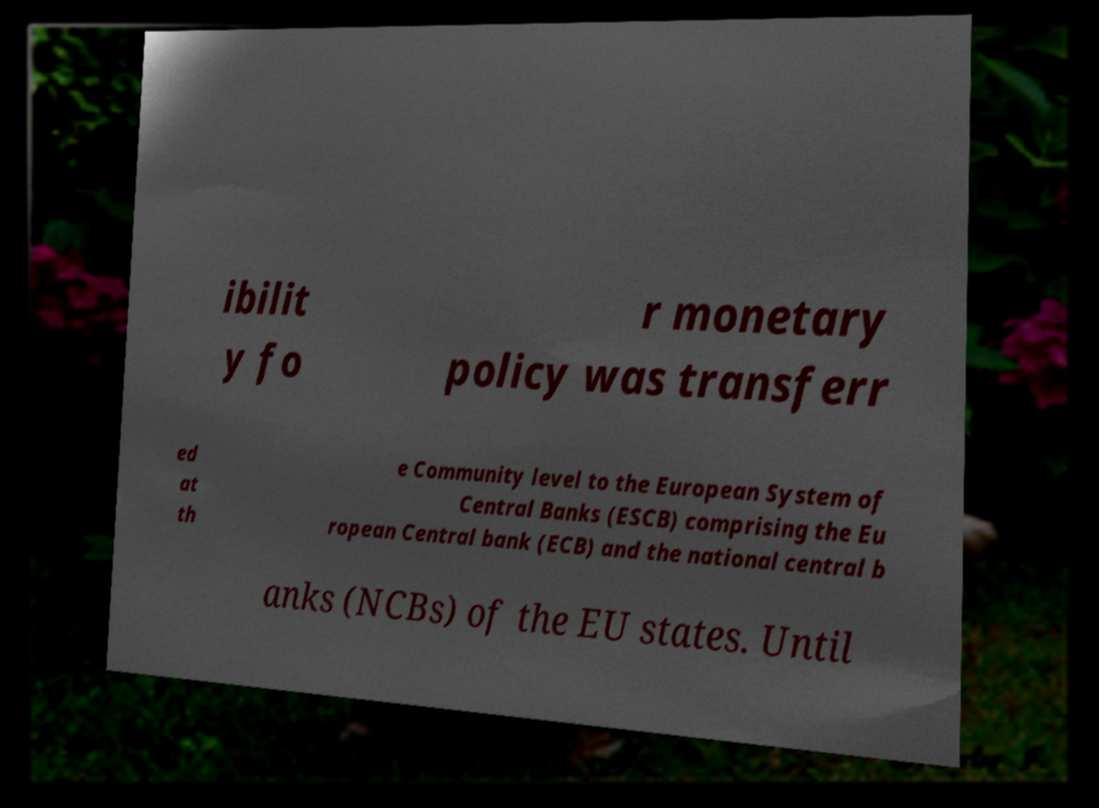There's text embedded in this image that I need extracted. Can you transcribe it verbatim? ibilit y fo r monetary policy was transferr ed at th e Community level to the European System of Central Banks (ESCB) comprising the Eu ropean Central bank (ECB) and the national central b anks (NCBs) of the EU states. Until 